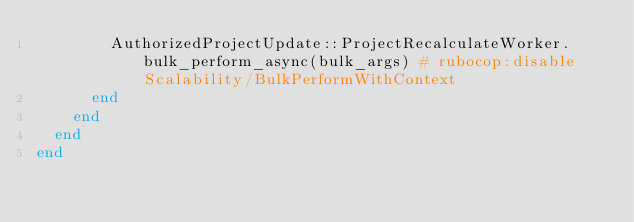Convert code to text. <code><loc_0><loc_0><loc_500><loc_500><_Ruby_>        AuthorizedProjectUpdate::ProjectRecalculateWorker.bulk_perform_async(bulk_args) # rubocop:disable Scalability/BulkPerformWithContext
      end
    end
  end
end
</code> 